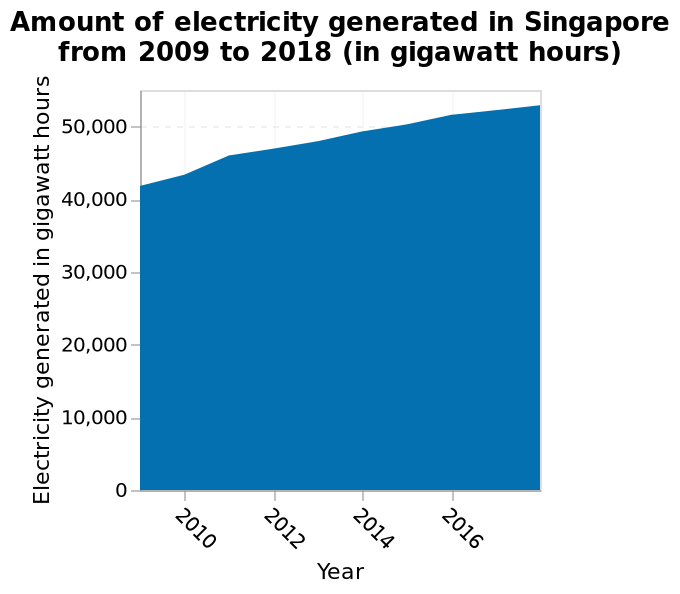<image>
please enumerates aspects of the construction of the chart Here a area graph is labeled Amount of electricity generated in Singapore from 2009 to 2018 (in gigawatt hours). There is a linear scale with a minimum of 2010 and a maximum of 2016 on the x-axis, labeled Year. Electricity generated in gigawatt hours is defined along a linear scale of range 0 to 50,000 along the y-axis. What is the trend in electricity generation between 2010 and 2016?  The trend in electricity generation between 2010 and 2016 is an increase. 